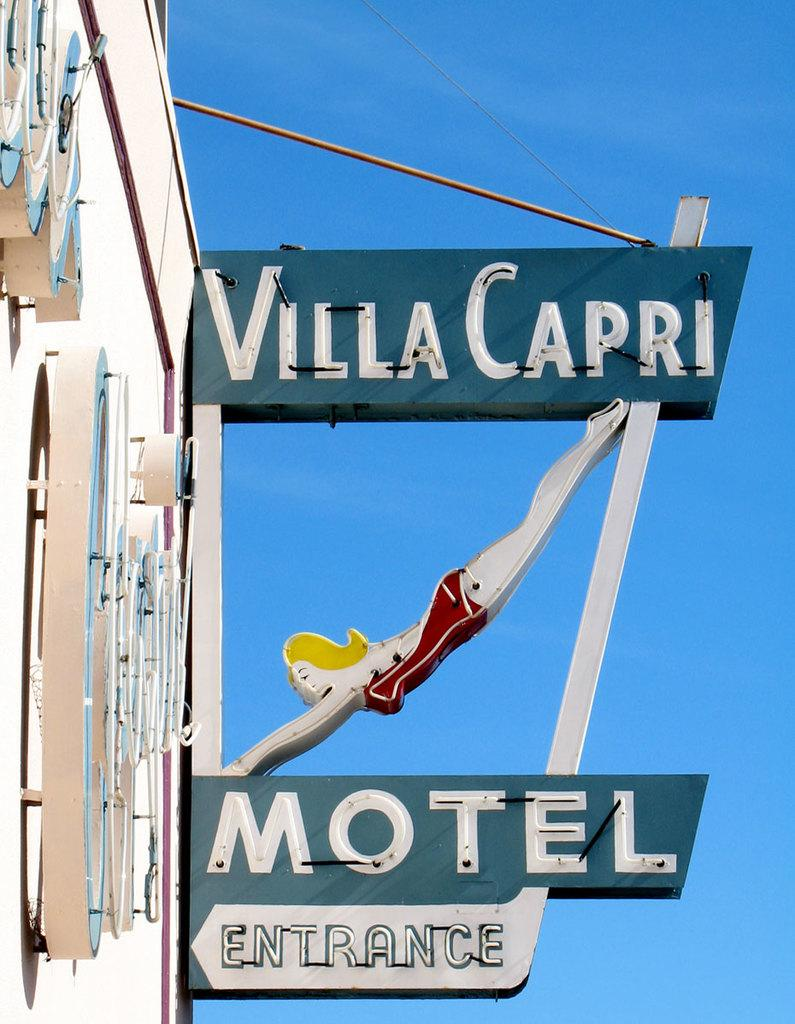<image>
Summarize the visual content of the image. an outside sign for the Villa Capri Motel entrance 